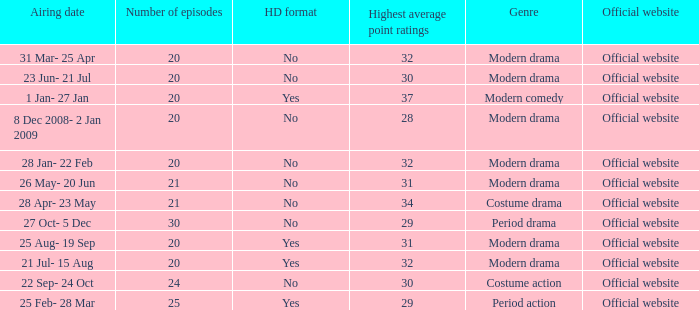I'm looking to parse the entire table for insights. Could you assist me with that? {'header': ['Airing date', 'Number of episodes', 'HD format', 'Highest average point ratings', 'Genre', 'Official website'], 'rows': [['31 Mar- 25 Apr', '20', 'No', '32', 'Modern drama', 'Official website'], ['23 Jun- 21 Jul', '20', 'No', '30', 'Modern drama', 'Official website'], ['1 Jan- 27 Jan', '20', 'Yes', '37', 'Modern comedy', 'Official website'], ['8 Dec 2008- 2 Jan 2009', '20', 'No', '28', 'Modern drama', 'Official website'], ['28 Jan- 22 Feb', '20', 'No', '32', 'Modern drama', 'Official website'], ['26 May- 20 Jun', '21', 'No', '31', 'Modern drama', 'Official website'], ['28 Apr- 23 May', '21', 'No', '34', 'Costume drama', 'Official website'], ['27 Oct- 5 Dec', '30', 'No', '29', 'Period drama', 'Official website'], ['25 Aug- 19 Sep', '20', 'Yes', '31', 'Modern drama', 'Official website'], ['21 Jul- 15 Aug', '20', 'Yes', '32', 'Modern drama', 'Official website'], ['22 Sep- 24 Oct', '24', 'No', '30', 'Costume action', 'Official website'], ['25 Feb- 28 Mar', '25', 'Yes', '29', 'Period action', 'Official website']]} What was the airing date when the number of episodes was larger than 20 and had the genre of costume action? 22 Sep- 24 Oct. 